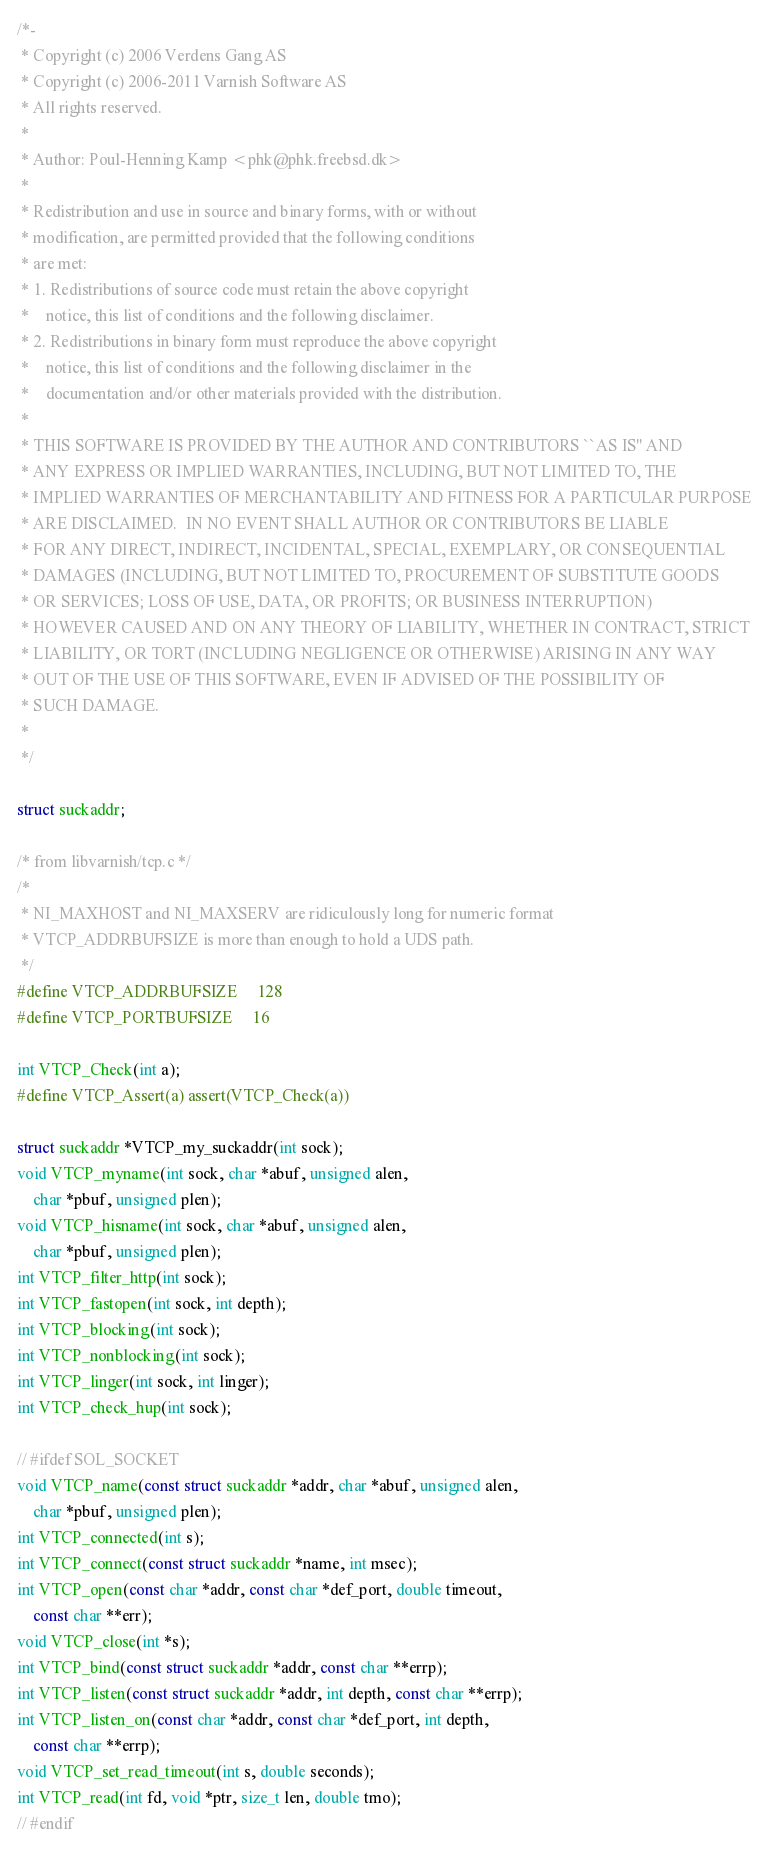Convert code to text. <code><loc_0><loc_0><loc_500><loc_500><_C_>/*-
 * Copyright (c) 2006 Verdens Gang AS
 * Copyright (c) 2006-2011 Varnish Software AS
 * All rights reserved.
 *
 * Author: Poul-Henning Kamp <phk@phk.freebsd.dk>
 *
 * Redistribution and use in source and binary forms, with or without
 * modification, are permitted provided that the following conditions
 * are met:
 * 1. Redistributions of source code must retain the above copyright
 *    notice, this list of conditions and the following disclaimer.
 * 2. Redistributions in binary form must reproduce the above copyright
 *    notice, this list of conditions and the following disclaimer in the
 *    documentation and/or other materials provided with the distribution.
 *
 * THIS SOFTWARE IS PROVIDED BY THE AUTHOR AND CONTRIBUTORS ``AS IS'' AND
 * ANY EXPRESS OR IMPLIED WARRANTIES, INCLUDING, BUT NOT LIMITED TO, THE
 * IMPLIED WARRANTIES OF MERCHANTABILITY AND FITNESS FOR A PARTICULAR PURPOSE
 * ARE DISCLAIMED.  IN NO EVENT SHALL AUTHOR OR CONTRIBUTORS BE LIABLE
 * FOR ANY DIRECT, INDIRECT, INCIDENTAL, SPECIAL, EXEMPLARY, OR CONSEQUENTIAL
 * DAMAGES (INCLUDING, BUT NOT LIMITED TO, PROCUREMENT OF SUBSTITUTE GOODS
 * OR SERVICES; LOSS OF USE, DATA, OR PROFITS; OR BUSINESS INTERRUPTION)
 * HOWEVER CAUSED AND ON ANY THEORY OF LIABILITY, WHETHER IN CONTRACT, STRICT
 * LIABILITY, OR TORT (INCLUDING NEGLIGENCE OR OTHERWISE) ARISING IN ANY WAY
 * OUT OF THE USE OF THIS SOFTWARE, EVEN IF ADVISED OF THE POSSIBILITY OF
 * SUCH DAMAGE.
 *
 */

struct suckaddr;

/* from libvarnish/tcp.c */
/*
 * NI_MAXHOST and NI_MAXSERV are ridiculously long for numeric format
 * VTCP_ADDRBUFSIZE is more than enough to hold a UDS path.
 */
#define VTCP_ADDRBUFSIZE		128
#define VTCP_PORTBUFSIZE		16

int VTCP_Check(int a);
#define VTCP_Assert(a) assert(VTCP_Check(a))

struct suckaddr *VTCP_my_suckaddr(int sock);
void VTCP_myname(int sock, char *abuf, unsigned alen,
    char *pbuf, unsigned plen);
void VTCP_hisname(int sock, char *abuf, unsigned alen,
    char *pbuf, unsigned plen);
int VTCP_filter_http(int sock);
int VTCP_fastopen(int sock, int depth);
int VTCP_blocking(int sock);
int VTCP_nonblocking(int sock);
int VTCP_linger(int sock, int linger);
int VTCP_check_hup(int sock);

// #ifdef SOL_SOCKET
void VTCP_name(const struct suckaddr *addr, char *abuf, unsigned alen,
    char *pbuf, unsigned plen);
int VTCP_connected(int s);
int VTCP_connect(const struct suckaddr *name, int msec);
int VTCP_open(const char *addr, const char *def_port, double timeout,
    const char **err);
void VTCP_close(int *s);
int VTCP_bind(const struct suckaddr *addr, const char **errp);
int VTCP_listen(const struct suckaddr *addr, int depth, const char **errp);
int VTCP_listen_on(const char *addr, const char *def_port, int depth,
    const char **errp);
void VTCP_set_read_timeout(int s, double seconds);
int VTCP_read(int fd, void *ptr, size_t len, double tmo);
// #endif
</code> 